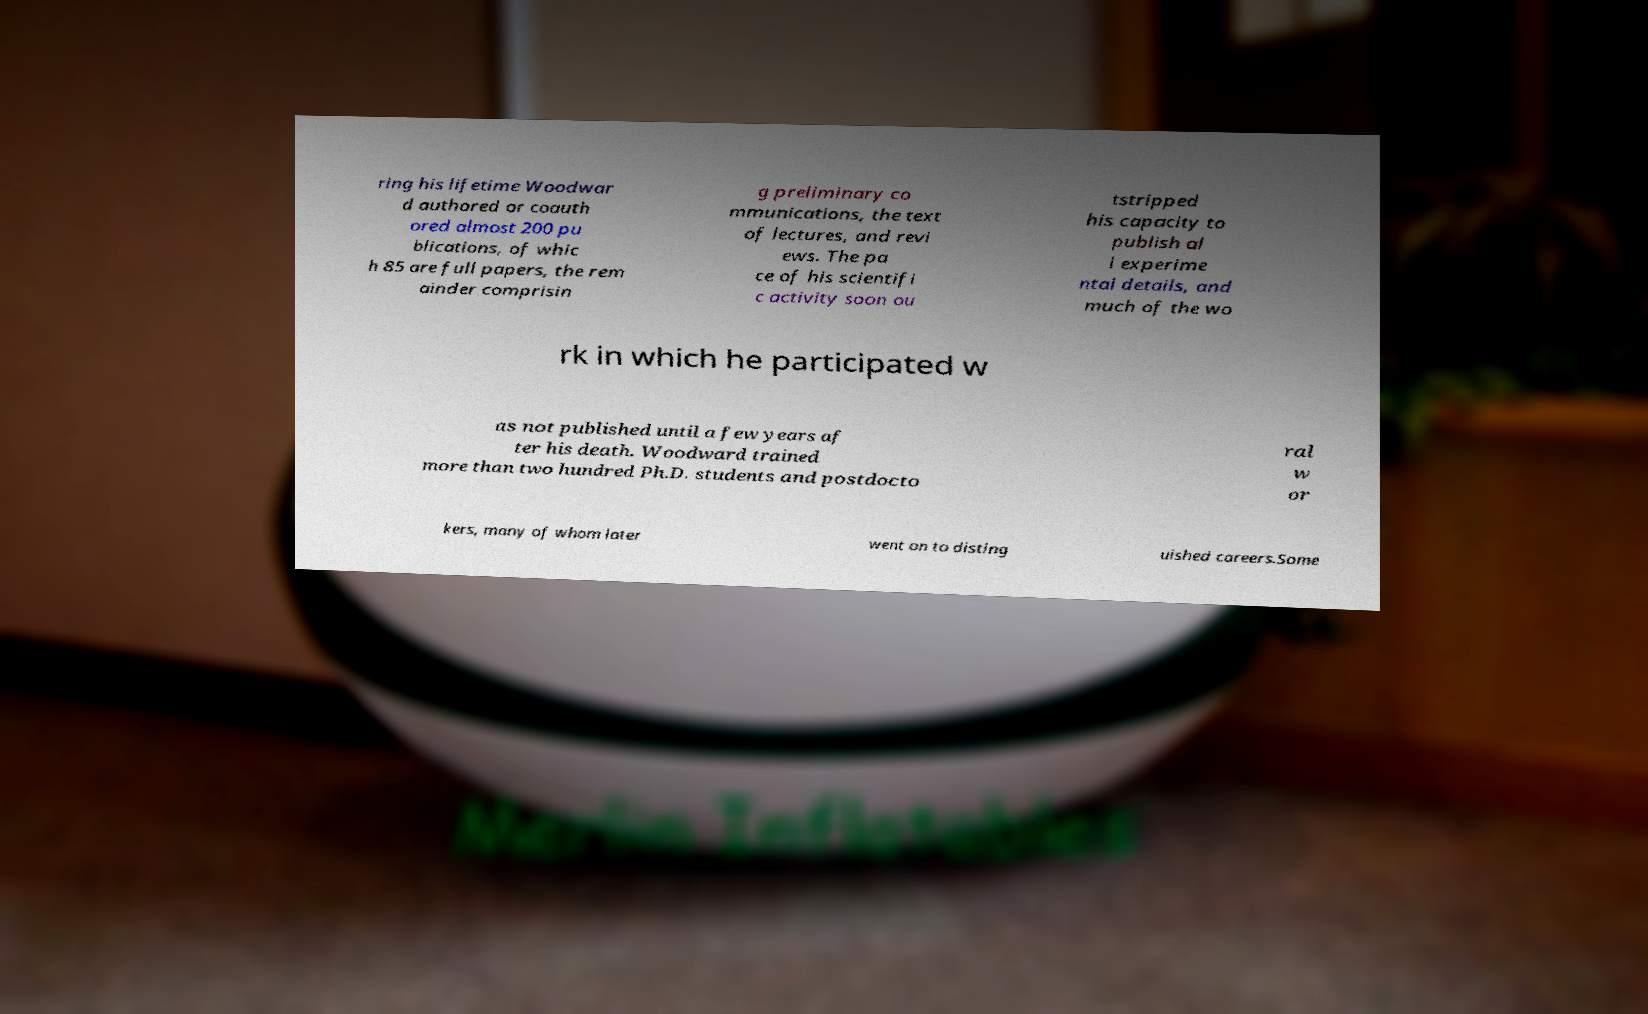Could you extract and type out the text from this image? ring his lifetime Woodwar d authored or coauth ored almost 200 pu blications, of whic h 85 are full papers, the rem ainder comprisin g preliminary co mmunications, the text of lectures, and revi ews. The pa ce of his scientifi c activity soon ou tstripped his capacity to publish al l experime ntal details, and much of the wo rk in which he participated w as not published until a few years af ter his death. Woodward trained more than two hundred Ph.D. students and postdocto ral w or kers, many of whom later went on to disting uished careers.Some 